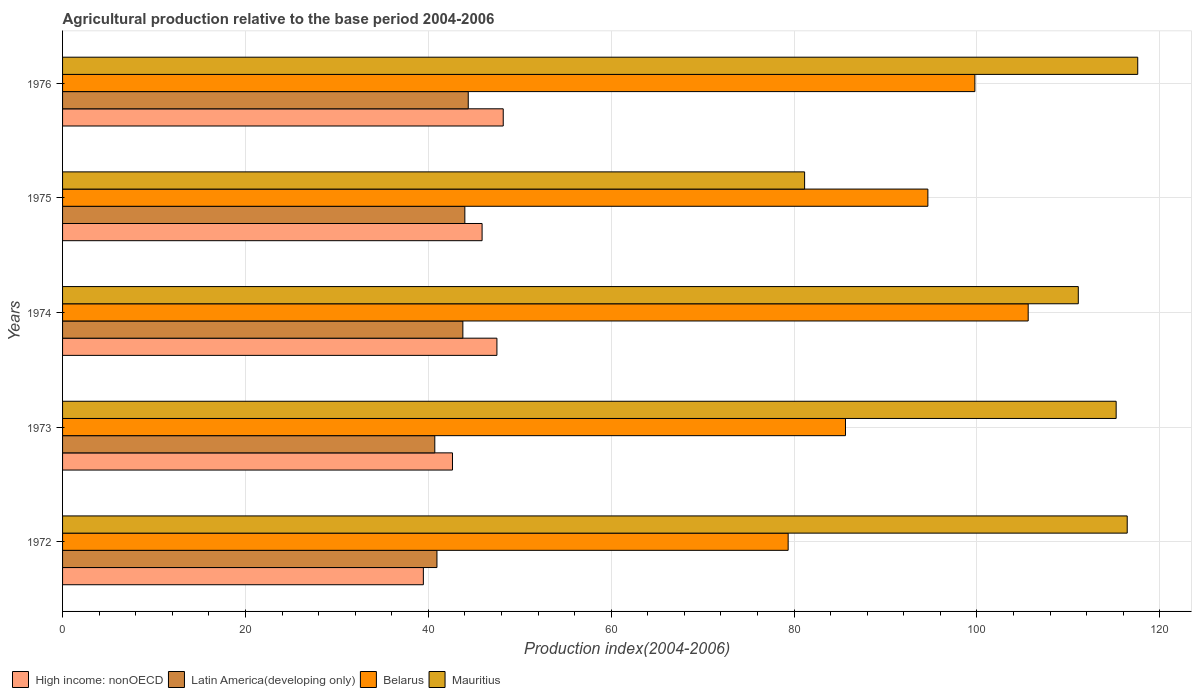How many bars are there on the 1st tick from the top?
Keep it short and to the point. 4. How many bars are there on the 4th tick from the bottom?
Offer a terse response. 4. What is the label of the 2nd group of bars from the top?
Your answer should be very brief. 1975. In how many cases, is the number of bars for a given year not equal to the number of legend labels?
Offer a very short reply. 0. What is the agricultural production index in Latin America(developing only) in 1974?
Your answer should be very brief. 43.78. Across all years, what is the maximum agricultural production index in High income: nonOECD?
Your answer should be compact. 48.19. Across all years, what is the minimum agricultural production index in Mauritius?
Your answer should be compact. 81.15. In which year was the agricultural production index in Mauritius maximum?
Your response must be concise. 1976. In which year was the agricultural production index in Mauritius minimum?
Keep it short and to the point. 1975. What is the total agricultural production index in Latin America(developing only) in the graph?
Provide a short and direct response. 213.79. What is the difference between the agricultural production index in Mauritius in 1973 and that in 1976?
Offer a very short reply. -2.36. What is the difference between the agricultural production index in Belarus in 1975 and the agricultural production index in Latin America(developing only) in 1974?
Your response must be concise. 50.85. What is the average agricultural production index in Mauritius per year?
Your response must be concise. 108.29. In the year 1975, what is the difference between the agricultural production index in High income: nonOECD and agricultural production index in Belarus?
Your response must be concise. -48.75. What is the ratio of the agricultural production index in Latin America(developing only) in 1974 to that in 1975?
Make the answer very short. 1. What is the difference between the highest and the second highest agricultural production index in High income: nonOECD?
Provide a short and direct response. 0.69. What is the difference between the highest and the lowest agricultural production index in Mauritius?
Your response must be concise. 36.43. Is the sum of the agricultural production index in Mauritius in 1972 and 1974 greater than the maximum agricultural production index in Latin America(developing only) across all years?
Your response must be concise. Yes. Is it the case that in every year, the sum of the agricultural production index in Mauritius and agricultural production index in High income: nonOECD is greater than the sum of agricultural production index in Latin America(developing only) and agricultural production index in Belarus?
Provide a succinct answer. No. What does the 2nd bar from the top in 1973 represents?
Your response must be concise. Belarus. What does the 4th bar from the bottom in 1973 represents?
Your answer should be compact. Mauritius. Is it the case that in every year, the sum of the agricultural production index in Latin America(developing only) and agricultural production index in Mauritius is greater than the agricultural production index in High income: nonOECD?
Keep it short and to the point. Yes. Are all the bars in the graph horizontal?
Keep it short and to the point. Yes. How many years are there in the graph?
Offer a terse response. 5. Does the graph contain grids?
Your response must be concise. Yes. How are the legend labels stacked?
Offer a very short reply. Horizontal. What is the title of the graph?
Provide a succinct answer. Agricultural production relative to the base period 2004-2006. What is the label or title of the X-axis?
Provide a short and direct response. Production index(2004-2006). What is the Production index(2004-2006) of High income: nonOECD in 1972?
Your answer should be very brief. 39.46. What is the Production index(2004-2006) of Latin America(developing only) in 1972?
Offer a terse response. 40.94. What is the Production index(2004-2006) in Belarus in 1972?
Give a very brief answer. 79.35. What is the Production index(2004-2006) in Mauritius in 1972?
Your answer should be very brief. 116.43. What is the Production index(2004-2006) in High income: nonOECD in 1973?
Ensure brevity in your answer.  42.64. What is the Production index(2004-2006) in Latin America(developing only) in 1973?
Ensure brevity in your answer.  40.71. What is the Production index(2004-2006) of Belarus in 1973?
Your answer should be compact. 85.62. What is the Production index(2004-2006) in Mauritius in 1973?
Your answer should be very brief. 115.22. What is the Production index(2004-2006) in High income: nonOECD in 1974?
Make the answer very short. 47.5. What is the Production index(2004-2006) of Latin America(developing only) in 1974?
Your response must be concise. 43.78. What is the Production index(2004-2006) of Belarus in 1974?
Your answer should be compact. 105.6. What is the Production index(2004-2006) in Mauritius in 1974?
Make the answer very short. 111.08. What is the Production index(2004-2006) in High income: nonOECD in 1975?
Ensure brevity in your answer.  45.88. What is the Production index(2004-2006) of Latin America(developing only) in 1975?
Your answer should be very brief. 43.99. What is the Production index(2004-2006) of Belarus in 1975?
Your answer should be very brief. 94.63. What is the Production index(2004-2006) of Mauritius in 1975?
Make the answer very short. 81.15. What is the Production index(2004-2006) of High income: nonOECD in 1976?
Your response must be concise. 48.19. What is the Production index(2004-2006) of Latin America(developing only) in 1976?
Offer a very short reply. 44.37. What is the Production index(2004-2006) in Belarus in 1976?
Provide a short and direct response. 99.77. What is the Production index(2004-2006) of Mauritius in 1976?
Make the answer very short. 117.58. Across all years, what is the maximum Production index(2004-2006) in High income: nonOECD?
Offer a terse response. 48.19. Across all years, what is the maximum Production index(2004-2006) of Latin America(developing only)?
Give a very brief answer. 44.37. Across all years, what is the maximum Production index(2004-2006) in Belarus?
Your response must be concise. 105.6. Across all years, what is the maximum Production index(2004-2006) of Mauritius?
Keep it short and to the point. 117.58. Across all years, what is the minimum Production index(2004-2006) in High income: nonOECD?
Your response must be concise. 39.46. Across all years, what is the minimum Production index(2004-2006) of Latin America(developing only)?
Your response must be concise. 40.71. Across all years, what is the minimum Production index(2004-2006) of Belarus?
Ensure brevity in your answer.  79.35. Across all years, what is the minimum Production index(2004-2006) of Mauritius?
Your answer should be very brief. 81.15. What is the total Production index(2004-2006) in High income: nonOECD in the graph?
Your answer should be very brief. 223.67. What is the total Production index(2004-2006) in Latin America(developing only) in the graph?
Keep it short and to the point. 213.79. What is the total Production index(2004-2006) of Belarus in the graph?
Keep it short and to the point. 464.97. What is the total Production index(2004-2006) of Mauritius in the graph?
Provide a short and direct response. 541.46. What is the difference between the Production index(2004-2006) in High income: nonOECD in 1972 and that in 1973?
Provide a succinct answer. -3.18. What is the difference between the Production index(2004-2006) in Latin America(developing only) in 1972 and that in 1973?
Offer a terse response. 0.24. What is the difference between the Production index(2004-2006) in Belarus in 1972 and that in 1973?
Your response must be concise. -6.27. What is the difference between the Production index(2004-2006) of Mauritius in 1972 and that in 1973?
Make the answer very short. 1.21. What is the difference between the Production index(2004-2006) in High income: nonOECD in 1972 and that in 1974?
Your answer should be compact. -8.04. What is the difference between the Production index(2004-2006) in Latin America(developing only) in 1972 and that in 1974?
Your response must be concise. -2.83. What is the difference between the Production index(2004-2006) of Belarus in 1972 and that in 1974?
Your answer should be compact. -26.25. What is the difference between the Production index(2004-2006) in Mauritius in 1972 and that in 1974?
Make the answer very short. 5.35. What is the difference between the Production index(2004-2006) in High income: nonOECD in 1972 and that in 1975?
Ensure brevity in your answer.  -6.42. What is the difference between the Production index(2004-2006) in Latin America(developing only) in 1972 and that in 1975?
Provide a short and direct response. -3.05. What is the difference between the Production index(2004-2006) in Belarus in 1972 and that in 1975?
Provide a succinct answer. -15.28. What is the difference between the Production index(2004-2006) in Mauritius in 1972 and that in 1975?
Give a very brief answer. 35.28. What is the difference between the Production index(2004-2006) in High income: nonOECD in 1972 and that in 1976?
Provide a short and direct response. -8.74. What is the difference between the Production index(2004-2006) in Latin America(developing only) in 1972 and that in 1976?
Ensure brevity in your answer.  -3.42. What is the difference between the Production index(2004-2006) of Belarus in 1972 and that in 1976?
Your response must be concise. -20.42. What is the difference between the Production index(2004-2006) of Mauritius in 1972 and that in 1976?
Ensure brevity in your answer.  -1.15. What is the difference between the Production index(2004-2006) of High income: nonOECD in 1973 and that in 1974?
Your response must be concise. -4.86. What is the difference between the Production index(2004-2006) in Latin America(developing only) in 1973 and that in 1974?
Provide a succinct answer. -3.07. What is the difference between the Production index(2004-2006) in Belarus in 1973 and that in 1974?
Provide a succinct answer. -19.98. What is the difference between the Production index(2004-2006) of Mauritius in 1973 and that in 1974?
Provide a succinct answer. 4.14. What is the difference between the Production index(2004-2006) in High income: nonOECD in 1973 and that in 1975?
Provide a short and direct response. -3.24. What is the difference between the Production index(2004-2006) in Latin America(developing only) in 1973 and that in 1975?
Provide a short and direct response. -3.28. What is the difference between the Production index(2004-2006) of Belarus in 1973 and that in 1975?
Your answer should be compact. -9.01. What is the difference between the Production index(2004-2006) of Mauritius in 1973 and that in 1975?
Your response must be concise. 34.07. What is the difference between the Production index(2004-2006) in High income: nonOECD in 1973 and that in 1976?
Your answer should be very brief. -5.55. What is the difference between the Production index(2004-2006) in Latin America(developing only) in 1973 and that in 1976?
Your answer should be very brief. -3.66. What is the difference between the Production index(2004-2006) in Belarus in 1973 and that in 1976?
Keep it short and to the point. -14.15. What is the difference between the Production index(2004-2006) in Mauritius in 1973 and that in 1976?
Ensure brevity in your answer.  -2.36. What is the difference between the Production index(2004-2006) of High income: nonOECD in 1974 and that in 1975?
Your answer should be very brief. 1.62. What is the difference between the Production index(2004-2006) in Latin America(developing only) in 1974 and that in 1975?
Your answer should be very brief. -0.22. What is the difference between the Production index(2004-2006) of Belarus in 1974 and that in 1975?
Provide a succinct answer. 10.97. What is the difference between the Production index(2004-2006) of Mauritius in 1974 and that in 1975?
Provide a succinct answer. 29.93. What is the difference between the Production index(2004-2006) in High income: nonOECD in 1974 and that in 1976?
Ensure brevity in your answer.  -0.69. What is the difference between the Production index(2004-2006) in Latin America(developing only) in 1974 and that in 1976?
Provide a short and direct response. -0.59. What is the difference between the Production index(2004-2006) of Belarus in 1974 and that in 1976?
Your answer should be compact. 5.83. What is the difference between the Production index(2004-2006) in Mauritius in 1974 and that in 1976?
Ensure brevity in your answer.  -6.5. What is the difference between the Production index(2004-2006) of High income: nonOECD in 1975 and that in 1976?
Offer a terse response. -2.31. What is the difference between the Production index(2004-2006) in Latin America(developing only) in 1975 and that in 1976?
Ensure brevity in your answer.  -0.37. What is the difference between the Production index(2004-2006) of Belarus in 1975 and that in 1976?
Offer a very short reply. -5.14. What is the difference between the Production index(2004-2006) in Mauritius in 1975 and that in 1976?
Your answer should be compact. -36.43. What is the difference between the Production index(2004-2006) of High income: nonOECD in 1972 and the Production index(2004-2006) of Latin America(developing only) in 1973?
Offer a terse response. -1.25. What is the difference between the Production index(2004-2006) of High income: nonOECD in 1972 and the Production index(2004-2006) of Belarus in 1973?
Give a very brief answer. -46.16. What is the difference between the Production index(2004-2006) in High income: nonOECD in 1972 and the Production index(2004-2006) in Mauritius in 1973?
Make the answer very short. -75.76. What is the difference between the Production index(2004-2006) of Latin America(developing only) in 1972 and the Production index(2004-2006) of Belarus in 1973?
Give a very brief answer. -44.68. What is the difference between the Production index(2004-2006) of Latin America(developing only) in 1972 and the Production index(2004-2006) of Mauritius in 1973?
Keep it short and to the point. -74.28. What is the difference between the Production index(2004-2006) of Belarus in 1972 and the Production index(2004-2006) of Mauritius in 1973?
Your answer should be very brief. -35.87. What is the difference between the Production index(2004-2006) of High income: nonOECD in 1972 and the Production index(2004-2006) of Latin America(developing only) in 1974?
Your answer should be very brief. -4.32. What is the difference between the Production index(2004-2006) in High income: nonOECD in 1972 and the Production index(2004-2006) in Belarus in 1974?
Make the answer very short. -66.14. What is the difference between the Production index(2004-2006) in High income: nonOECD in 1972 and the Production index(2004-2006) in Mauritius in 1974?
Your answer should be very brief. -71.62. What is the difference between the Production index(2004-2006) in Latin America(developing only) in 1972 and the Production index(2004-2006) in Belarus in 1974?
Provide a short and direct response. -64.66. What is the difference between the Production index(2004-2006) in Latin America(developing only) in 1972 and the Production index(2004-2006) in Mauritius in 1974?
Make the answer very short. -70.14. What is the difference between the Production index(2004-2006) of Belarus in 1972 and the Production index(2004-2006) of Mauritius in 1974?
Your answer should be very brief. -31.73. What is the difference between the Production index(2004-2006) in High income: nonOECD in 1972 and the Production index(2004-2006) in Latin America(developing only) in 1975?
Provide a succinct answer. -4.54. What is the difference between the Production index(2004-2006) in High income: nonOECD in 1972 and the Production index(2004-2006) in Belarus in 1975?
Keep it short and to the point. -55.17. What is the difference between the Production index(2004-2006) in High income: nonOECD in 1972 and the Production index(2004-2006) in Mauritius in 1975?
Provide a succinct answer. -41.69. What is the difference between the Production index(2004-2006) of Latin America(developing only) in 1972 and the Production index(2004-2006) of Belarus in 1975?
Ensure brevity in your answer.  -53.69. What is the difference between the Production index(2004-2006) in Latin America(developing only) in 1972 and the Production index(2004-2006) in Mauritius in 1975?
Provide a succinct answer. -40.21. What is the difference between the Production index(2004-2006) in High income: nonOECD in 1972 and the Production index(2004-2006) in Latin America(developing only) in 1976?
Offer a terse response. -4.91. What is the difference between the Production index(2004-2006) in High income: nonOECD in 1972 and the Production index(2004-2006) in Belarus in 1976?
Offer a very short reply. -60.31. What is the difference between the Production index(2004-2006) in High income: nonOECD in 1972 and the Production index(2004-2006) in Mauritius in 1976?
Give a very brief answer. -78.12. What is the difference between the Production index(2004-2006) of Latin America(developing only) in 1972 and the Production index(2004-2006) of Belarus in 1976?
Ensure brevity in your answer.  -58.83. What is the difference between the Production index(2004-2006) in Latin America(developing only) in 1972 and the Production index(2004-2006) in Mauritius in 1976?
Offer a terse response. -76.64. What is the difference between the Production index(2004-2006) in Belarus in 1972 and the Production index(2004-2006) in Mauritius in 1976?
Offer a very short reply. -38.23. What is the difference between the Production index(2004-2006) of High income: nonOECD in 1973 and the Production index(2004-2006) of Latin America(developing only) in 1974?
Give a very brief answer. -1.14. What is the difference between the Production index(2004-2006) of High income: nonOECD in 1973 and the Production index(2004-2006) of Belarus in 1974?
Provide a short and direct response. -62.96. What is the difference between the Production index(2004-2006) in High income: nonOECD in 1973 and the Production index(2004-2006) in Mauritius in 1974?
Keep it short and to the point. -68.44. What is the difference between the Production index(2004-2006) in Latin America(developing only) in 1973 and the Production index(2004-2006) in Belarus in 1974?
Keep it short and to the point. -64.89. What is the difference between the Production index(2004-2006) in Latin America(developing only) in 1973 and the Production index(2004-2006) in Mauritius in 1974?
Offer a terse response. -70.37. What is the difference between the Production index(2004-2006) of Belarus in 1973 and the Production index(2004-2006) of Mauritius in 1974?
Make the answer very short. -25.46. What is the difference between the Production index(2004-2006) in High income: nonOECD in 1973 and the Production index(2004-2006) in Latin America(developing only) in 1975?
Offer a very short reply. -1.35. What is the difference between the Production index(2004-2006) of High income: nonOECD in 1973 and the Production index(2004-2006) of Belarus in 1975?
Offer a terse response. -51.99. What is the difference between the Production index(2004-2006) in High income: nonOECD in 1973 and the Production index(2004-2006) in Mauritius in 1975?
Make the answer very short. -38.51. What is the difference between the Production index(2004-2006) of Latin America(developing only) in 1973 and the Production index(2004-2006) of Belarus in 1975?
Offer a very short reply. -53.92. What is the difference between the Production index(2004-2006) of Latin America(developing only) in 1973 and the Production index(2004-2006) of Mauritius in 1975?
Provide a short and direct response. -40.44. What is the difference between the Production index(2004-2006) in Belarus in 1973 and the Production index(2004-2006) in Mauritius in 1975?
Provide a short and direct response. 4.47. What is the difference between the Production index(2004-2006) in High income: nonOECD in 1973 and the Production index(2004-2006) in Latin America(developing only) in 1976?
Provide a succinct answer. -1.73. What is the difference between the Production index(2004-2006) of High income: nonOECD in 1973 and the Production index(2004-2006) of Belarus in 1976?
Ensure brevity in your answer.  -57.13. What is the difference between the Production index(2004-2006) in High income: nonOECD in 1973 and the Production index(2004-2006) in Mauritius in 1976?
Keep it short and to the point. -74.94. What is the difference between the Production index(2004-2006) of Latin America(developing only) in 1973 and the Production index(2004-2006) of Belarus in 1976?
Give a very brief answer. -59.06. What is the difference between the Production index(2004-2006) of Latin America(developing only) in 1973 and the Production index(2004-2006) of Mauritius in 1976?
Offer a very short reply. -76.87. What is the difference between the Production index(2004-2006) of Belarus in 1973 and the Production index(2004-2006) of Mauritius in 1976?
Keep it short and to the point. -31.96. What is the difference between the Production index(2004-2006) in High income: nonOECD in 1974 and the Production index(2004-2006) in Latin America(developing only) in 1975?
Keep it short and to the point. 3.51. What is the difference between the Production index(2004-2006) of High income: nonOECD in 1974 and the Production index(2004-2006) of Belarus in 1975?
Your answer should be compact. -47.13. What is the difference between the Production index(2004-2006) of High income: nonOECD in 1974 and the Production index(2004-2006) of Mauritius in 1975?
Your answer should be very brief. -33.65. What is the difference between the Production index(2004-2006) in Latin America(developing only) in 1974 and the Production index(2004-2006) in Belarus in 1975?
Your answer should be very brief. -50.85. What is the difference between the Production index(2004-2006) of Latin America(developing only) in 1974 and the Production index(2004-2006) of Mauritius in 1975?
Keep it short and to the point. -37.37. What is the difference between the Production index(2004-2006) in Belarus in 1974 and the Production index(2004-2006) in Mauritius in 1975?
Your response must be concise. 24.45. What is the difference between the Production index(2004-2006) of High income: nonOECD in 1974 and the Production index(2004-2006) of Latin America(developing only) in 1976?
Ensure brevity in your answer.  3.13. What is the difference between the Production index(2004-2006) of High income: nonOECD in 1974 and the Production index(2004-2006) of Belarus in 1976?
Your answer should be compact. -52.27. What is the difference between the Production index(2004-2006) in High income: nonOECD in 1974 and the Production index(2004-2006) in Mauritius in 1976?
Your answer should be compact. -70.08. What is the difference between the Production index(2004-2006) of Latin America(developing only) in 1974 and the Production index(2004-2006) of Belarus in 1976?
Your answer should be compact. -55.99. What is the difference between the Production index(2004-2006) in Latin America(developing only) in 1974 and the Production index(2004-2006) in Mauritius in 1976?
Keep it short and to the point. -73.8. What is the difference between the Production index(2004-2006) in Belarus in 1974 and the Production index(2004-2006) in Mauritius in 1976?
Keep it short and to the point. -11.98. What is the difference between the Production index(2004-2006) in High income: nonOECD in 1975 and the Production index(2004-2006) in Latin America(developing only) in 1976?
Give a very brief answer. 1.51. What is the difference between the Production index(2004-2006) in High income: nonOECD in 1975 and the Production index(2004-2006) in Belarus in 1976?
Ensure brevity in your answer.  -53.89. What is the difference between the Production index(2004-2006) of High income: nonOECD in 1975 and the Production index(2004-2006) of Mauritius in 1976?
Offer a terse response. -71.7. What is the difference between the Production index(2004-2006) in Latin America(developing only) in 1975 and the Production index(2004-2006) in Belarus in 1976?
Offer a very short reply. -55.78. What is the difference between the Production index(2004-2006) of Latin America(developing only) in 1975 and the Production index(2004-2006) of Mauritius in 1976?
Ensure brevity in your answer.  -73.59. What is the difference between the Production index(2004-2006) of Belarus in 1975 and the Production index(2004-2006) of Mauritius in 1976?
Keep it short and to the point. -22.95. What is the average Production index(2004-2006) of High income: nonOECD per year?
Offer a terse response. 44.73. What is the average Production index(2004-2006) of Latin America(developing only) per year?
Provide a succinct answer. 42.76. What is the average Production index(2004-2006) of Belarus per year?
Offer a very short reply. 92.99. What is the average Production index(2004-2006) of Mauritius per year?
Offer a very short reply. 108.29. In the year 1972, what is the difference between the Production index(2004-2006) in High income: nonOECD and Production index(2004-2006) in Latin America(developing only)?
Your answer should be very brief. -1.49. In the year 1972, what is the difference between the Production index(2004-2006) in High income: nonOECD and Production index(2004-2006) in Belarus?
Give a very brief answer. -39.89. In the year 1972, what is the difference between the Production index(2004-2006) in High income: nonOECD and Production index(2004-2006) in Mauritius?
Your answer should be compact. -76.97. In the year 1972, what is the difference between the Production index(2004-2006) of Latin America(developing only) and Production index(2004-2006) of Belarus?
Your answer should be compact. -38.41. In the year 1972, what is the difference between the Production index(2004-2006) of Latin America(developing only) and Production index(2004-2006) of Mauritius?
Make the answer very short. -75.49. In the year 1972, what is the difference between the Production index(2004-2006) of Belarus and Production index(2004-2006) of Mauritius?
Offer a very short reply. -37.08. In the year 1973, what is the difference between the Production index(2004-2006) in High income: nonOECD and Production index(2004-2006) in Latin America(developing only)?
Keep it short and to the point. 1.93. In the year 1973, what is the difference between the Production index(2004-2006) in High income: nonOECD and Production index(2004-2006) in Belarus?
Provide a succinct answer. -42.98. In the year 1973, what is the difference between the Production index(2004-2006) in High income: nonOECD and Production index(2004-2006) in Mauritius?
Keep it short and to the point. -72.58. In the year 1973, what is the difference between the Production index(2004-2006) of Latin America(developing only) and Production index(2004-2006) of Belarus?
Your answer should be very brief. -44.91. In the year 1973, what is the difference between the Production index(2004-2006) in Latin America(developing only) and Production index(2004-2006) in Mauritius?
Offer a very short reply. -74.51. In the year 1973, what is the difference between the Production index(2004-2006) of Belarus and Production index(2004-2006) of Mauritius?
Provide a short and direct response. -29.6. In the year 1974, what is the difference between the Production index(2004-2006) of High income: nonOECD and Production index(2004-2006) of Latin America(developing only)?
Offer a terse response. 3.72. In the year 1974, what is the difference between the Production index(2004-2006) in High income: nonOECD and Production index(2004-2006) in Belarus?
Provide a short and direct response. -58.1. In the year 1974, what is the difference between the Production index(2004-2006) in High income: nonOECD and Production index(2004-2006) in Mauritius?
Provide a short and direct response. -63.58. In the year 1974, what is the difference between the Production index(2004-2006) of Latin America(developing only) and Production index(2004-2006) of Belarus?
Keep it short and to the point. -61.82. In the year 1974, what is the difference between the Production index(2004-2006) in Latin America(developing only) and Production index(2004-2006) in Mauritius?
Make the answer very short. -67.3. In the year 1974, what is the difference between the Production index(2004-2006) in Belarus and Production index(2004-2006) in Mauritius?
Your answer should be very brief. -5.48. In the year 1975, what is the difference between the Production index(2004-2006) of High income: nonOECD and Production index(2004-2006) of Latin America(developing only)?
Ensure brevity in your answer.  1.89. In the year 1975, what is the difference between the Production index(2004-2006) in High income: nonOECD and Production index(2004-2006) in Belarus?
Give a very brief answer. -48.75. In the year 1975, what is the difference between the Production index(2004-2006) in High income: nonOECD and Production index(2004-2006) in Mauritius?
Give a very brief answer. -35.27. In the year 1975, what is the difference between the Production index(2004-2006) in Latin America(developing only) and Production index(2004-2006) in Belarus?
Offer a terse response. -50.64. In the year 1975, what is the difference between the Production index(2004-2006) in Latin America(developing only) and Production index(2004-2006) in Mauritius?
Your answer should be compact. -37.16. In the year 1975, what is the difference between the Production index(2004-2006) in Belarus and Production index(2004-2006) in Mauritius?
Your answer should be very brief. 13.48. In the year 1976, what is the difference between the Production index(2004-2006) in High income: nonOECD and Production index(2004-2006) in Latin America(developing only)?
Offer a terse response. 3.83. In the year 1976, what is the difference between the Production index(2004-2006) in High income: nonOECD and Production index(2004-2006) in Belarus?
Your answer should be compact. -51.58. In the year 1976, what is the difference between the Production index(2004-2006) in High income: nonOECD and Production index(2004-2006) in Mauritius?
Ensure brevity in your answer.  -69.39. In the year 1976, what is the difference between the Production index(2004-2006) in Latin America(developing only) and Production index(2004-2006) in Belarus?
Give a very brief answer. -55.4. In the year 1976, what is the difference between the Production index(2004-2006) of Latin America(developing only) and Production index(2004-2006) of Mauritius?
Provide a succinct answer. -73.21. In the year 1976, what is the difference between the Production index(2004-2006) in Belarus and Production index(2004-2006) in Mauritius?
Provide a short and direct response. -17.81. What is the ratio of the Production index(2004-2006) of High income: nonOECD in 1972 to that in 1973?
Ensure brevity in your answer.  0.93. What is the ratio of the Production index(2004-2006) of Belarus in 1972 to that in 1973?
Give a very brief answer. 0.93. What is the ratio of the Production index(2004-2006) of Mauritius in 1972 to that in 1973?
Your answer should be compact. 1.01. What is the ratio of the Production index(2004-2006) in High income: nonOECD in 1972 to that in 1974?
Your answer should be compact. 0.83. What is the ratio of the Production index(2004-2006) of Latin America(developing only) in 1972 to that in 1974?
Your response must be concise. 0.94. What is the ratio of the Production index(2004-2006) of Belarus in 1972 to that in 1974?
Your answer should be very brief. 0.75. What is the ratio of the Production index(2004-2006) of Mauritius in 1972 to that in 1974?
Your answer should be compact. 1.05. What is the ratio of the Production index(2004-2006) of High income: nonOECD in 1972 to that in 1975?
Your response must be concise. 0.86. What is the ratio of the Production index(2004-2006) of Latin America(developing only) in 1972 to that in 1975?
Provide a succinct answer. 0.93. What is the ratio of the Production index(2004-2006) in Belarus in 1972 to that in 1975?
Ensure brevity in your answer.  0.84. What is the ratio of the Production index(2004-2006) of Mauritius in 1972 to that in 1975?
Ensure brevity in your answer.  1.43. What is the ratio of the Production index(2004-2006) of High income: nonOECD in 1972 to that in 1976?
Make the answer very short. 0.82. What is the ratio of the Production index(2004-2006) in Latin America(developing only) in 1972 to that in 1976?
Your answer should be very brief. 0.92. What is the ratio of the Production index(2004-2006) in Belarus in 1972 to that in 1976?
Ensure brevity in your answer.  0.8. What is the ratio of the Production index(2004-2006) in Mauritius in 1972 to that in 1976?
Your answer should be very brief. 0.99. What is the ratio of the Production index(2004-2006) in High income: nonOECD in 1973 to that in 1974?
Offer a very short reply. 0.9. What is the ratio of the Production index(2004-2006) of Latin America(developing only) in 1973 to that in 1974?
Provide a short and direct response. 0.93. What is the ratio of the Production index(2004-2006) of Belarus in 1973 to that in 1974?
Offer a terse response. 0.81. What is the ratio of the Production index(2004-2006) in Mauritius in 1973 to that in 1974?
Give a very brief answer. 1.04. What is the ratio of the Production index(2004-2006) in High income: nonOECD in 1973 to that in 1975?
Give a very brief answer. 0.93. What is the ratio of the Production index(2004-2006) in Latin America(developing only) in 1973 to that in 1975?
Keep it short and to the point. 0.93. What is the ratio of the Production index(2004-2006) in Belarus in 1973 to that in 1975?
Give a very brief answer. 0.9. What is the ratio of the Production index(2004-2006) of Mauritius in 1973 to that in 1975?
Make the answer very short. 1.42. What is the ratio of the Production index(2004-2006) of High income: nonOECD in 1973 to that in 1976?
Offer a terse response. 0.88. What is the ratio of the Production index(2004-2006) of Latin America(developing only) in 1973 to that in 1976?
Your answer should be very brief. 0.92. What is the ratio of the Production index(2004-2006) in Belarus in 1973 to that in 1976?
Keep it short and to the point. 0.86. What is the ratio of the Production index(2004-2006) in Mauritius in 1973 to that in 1976?
Provide a succinct answer. 0.98. What is the ratio of the Production index(2004-2006) in High income: nonOECD in 1974 to that in 1975?
Your answer should be very brief. 1.04. What is the ratio of the Production index(2004-2006) in Belarus in 1974 to that in 1975?
Your answer should be very brief. 1.12. What is the ratio of the Production index(2004-2006) in Mauritius in 1974 to that in 1975?
Your answer should be very brief. 1.37. What is the ratio of the Production index(2004-2006) of High income: nonOECD in 1974 to that in 1976?
Make the answer very short. 0.99. What is the ratio of the Production index(2004-2006) in Latin America(developing only) in 1974 to that in 1976?
Make the answer very short. 0.99. What is the ratio of the Production index(2004-2006) of Belarus in 1974 to that in 1976?
Ensure brevity in your answer.  1.06. What is the ratio of the Production index(2004-2006) of Mauritius in 1974 to that in 1976?
Offer a terse response. 0.94. What is the ratio of the Production index(2004-2006) in Belarus in 1975 to that in 1976?
Offer a terse response. 0.95. What is the ratio of the Production index(2004-2006) in Mauritius in 1975 to that in 1976?
Your answer should be very brief. 0.69. What is the difference between the highest and the second highest Production index(2004-2006) in High income: nonOECD?
Your answer should be compact. 0.69. What is the difference between the highest and the second highest Production index(2004-2006) in Latin America(developing only)?
Provide a short and direct response. 0.37. What is the difference between the highest and the second highest Production index(2004-2006) of Belarus?
Your response must be concise. 5.83. What is the difference between the highest and the second highest Production index(2004-2006) in Mauritius?
Provide a succinct answer. 1.15. What is the difference between the highest and the lowest Production index(2004-2006) of High income: nonOECD?
Your answer should be very brief. 8.74. What is the difference between the highest and the lowest Production index(2004-2006) of Latin America(developing only)?
Make the answer very short. 3.66. What is the difference between the highest and the lowest Production index(2004-2006) of Belarus?
Offer a terse response. 26.25. What is the difference between the highest and the lowest Production index(2004-2006) in Mauritius?
Provide a short and direct response. 36.43. 